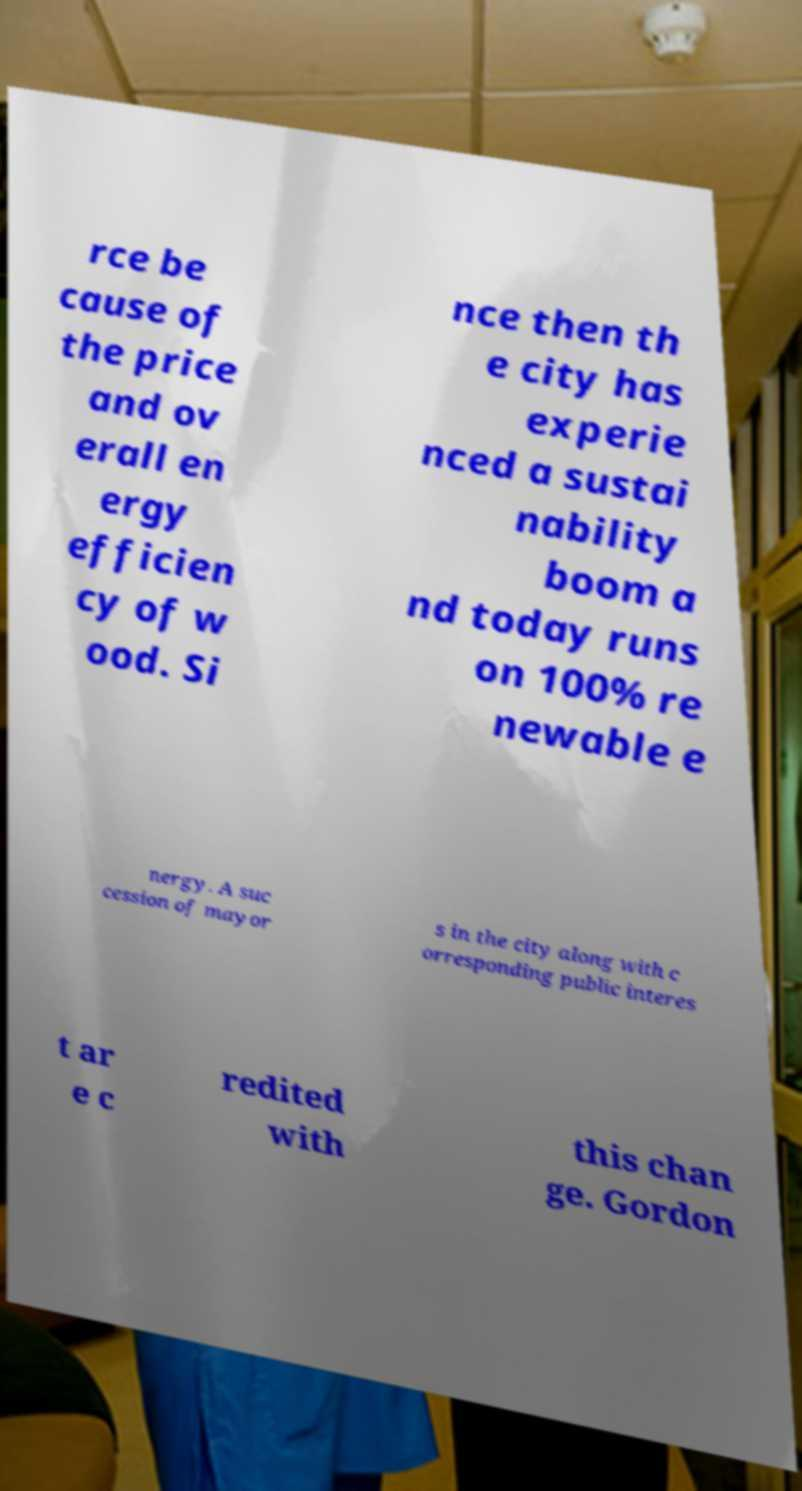Please read and relay the text visible in this image. What does it say? rce be cause of the price and ov erall en ergy efficien cy of w ood. Si nce then th e city has experie nced a sustai nability boom a nd today runs on 100% re newable e nergy. A suc cession of mayor s in the city along with c orresponding public interes t ar e c redited with this chan ge. Gordon 